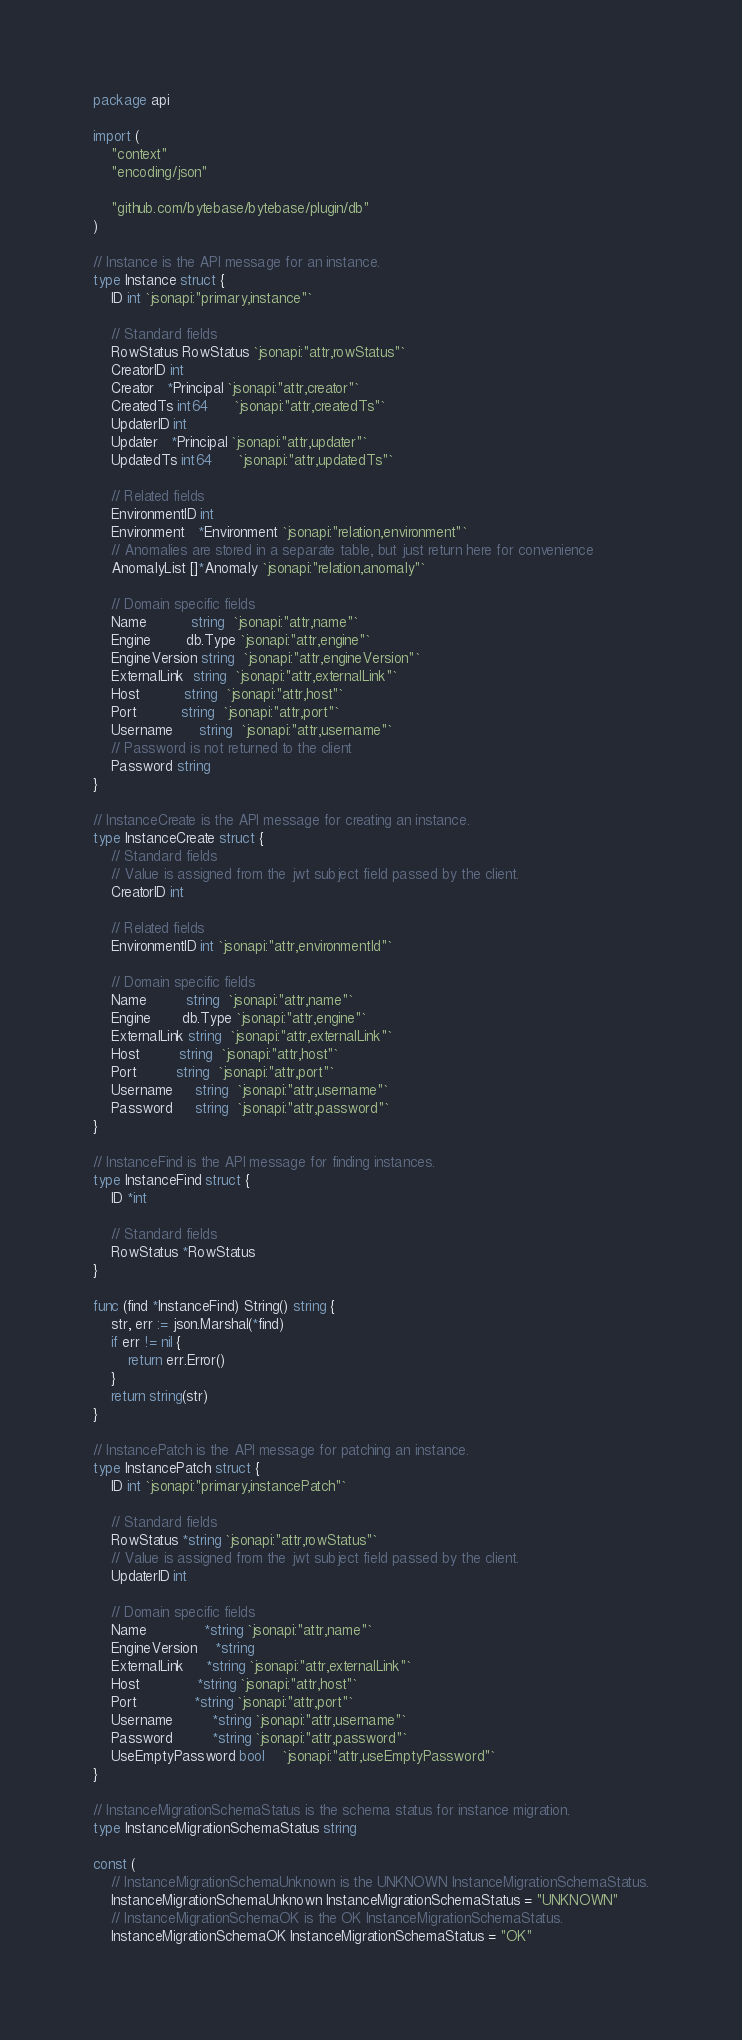Convert code to text. <code><loc_0><loc_0><loc_500><loc_500><_Go_>package api

import (
	"context"
	"encoding/json"

	"github.com/bytebase/bytebase/plugin/db"
)

// Instance is the API message for an instance.
type Instance struct {
	ID int `jsonapi:"primary,instance"`

	// Standard fields
	RowStatus RowStatus `jsonapi:"attr,rowStatus"`
	CreatorID int
	Creator   *Principal `jsonapi:"attr,creator"`
	CreatedTs int64      `jsonapi:"attr,createdTs"`
	UpdaterID int
	Updater   *Principal `jsonapi:"attr,updater"`
	UpdatedTs int64      `jsonapi:"attr,updatedTs"`

	// Related fields
	EnvironmentID int
	Environment   *Environment `jsonapi:"relation,environment"`
	// Anomalies are stored in a separate table, but just return here for convenience
	AnomalyList []*Anomaly `jsonapi:"relation,anomaly"`

	// Domain specific fields
	Name          string  `jsonapi:"attr,name"`
	Engine        db.Type `jsonapi:"attr,engine"`
	EngineVersion string  `jsonapi:"attr,engineVersion"`
	ExternalLink  string  `jsonapi:"attr,externalLink"`
	Host          string  `jsonapi:"attr,host"`
	Port          string  `jsonapi:"attr,port"`
	Username      string  `jsonapi:"attr,username"`
	// Password is not returned to the client
	Password string
}

// InstanceCreate is the API message for creating an instance.
type InstanceCreate struct {
	// Standard fields
	// Value is assigned from the jwt subject field passed by the client.
	CreatorID int

	// Related fields
	EnvironmentID int `jsonapi:"attr,environmentId"`

	// Domain specific fields
	Name         string  `jsonapi:"attr,name"`
	Engine       db.Type `jsonapi:"attr,engine"`
	ExternalLink string  `jsonapi:"attr,externalLink"`
	Host         string  `jsonapi:"attr,host"`
	Port         string  `jsonapi:"attr,port"`
	Username     string  `jsonapi:"attr,username"`
	Password     string  `jsonapi:"attr,password"`
}

// InstanceFind is the API message for finding instances.
type InstanceFind struct {
	ID *int

	// Standard fields
	RowStatus *RowStatus
}

func (find *InstanceFind) String() string {
	str, err := json.Marshal(*find)
	if err != nil {
		return err.Error()
	}
	return string(str)
}

// InstancePatch is the API message for patching an instance.
type InstancePatch struct {
	ID int `jsonapi:"primary,instancePatch"`

	// Standard fields
	RowStatus *string `jsonapi:"attr,rowStatus"`
	// Value is assigned from the jwt subject field passed by the client.
	UpdaterID int

	// Domain specific fields
	Name             *string `jsonapi:"attr,name"`
	EngineVersion    *string
	ExternalLink     *string `jsonapi:"attr,externalLink"`
	Host             *string `jsonapi:"attr,host"`
	Port             *string `jsonapi:"attr,port"`
	Username         *string `jsonapi:"attr,username"`
	Password         *string `jsonapi:"attr,password"`
	UseEmptyPassword bool    `jsonapi:"attr,useEmptyPassword"`
}

// InstanceMigrationSchemaStatus is the schema status for instance migration.
type InstanceMigrationSchemaStatus string

const (
	// InstanceMigrationSchemaUnknown is the UNKNOWN InstanceMigrationSchemaStatus.
	InstanceMigrationSchemaUnknown InstanceMigrationSchemaStatus = "UNKNOWN"
	// InstanceMigrationSchemaOK is the OK InstanceMigrationSchemaStatus.
	InstanceMigrationSchemaOK InstanceMigrationSchemaStatus = "OK"</code> 